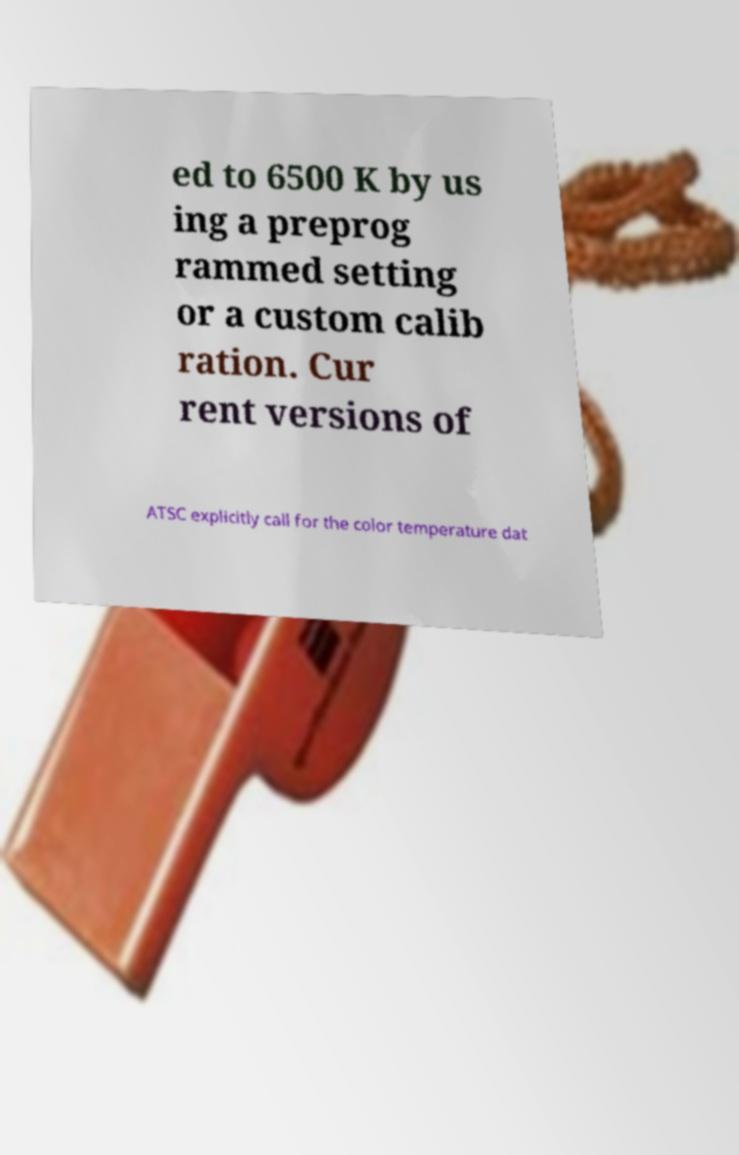Could you extract and type out the text from this image? ed to 6500 K by us ing a preprog rammed setting or a custom calib ration. Cur rent versions of ATSC explicitly call for the color temperature dat 